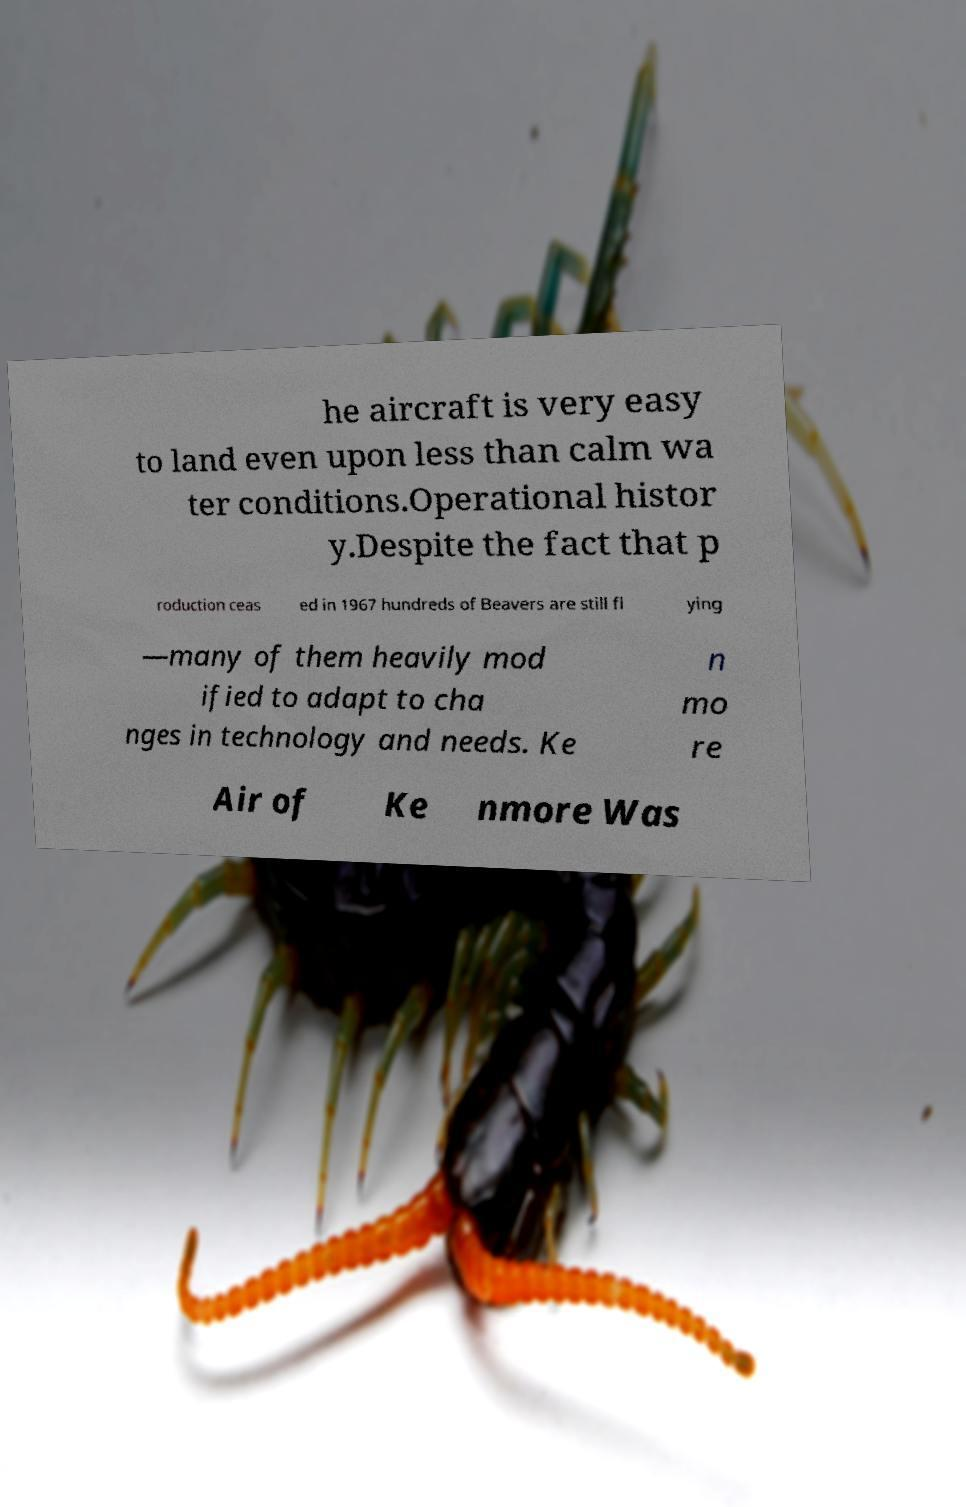Please identify and transcribe the text found in this image. he aircraft is very easy to land even upon less than calm wa ter conditions.Operational histor y.Despite the fact that p roduction ceas ed in 1967 hundreds of Beavers are still fl ying —many of them heavily mod ified to adapt to cha nges in technology and needs. Ke n mo re Air of Ke nmore Was 